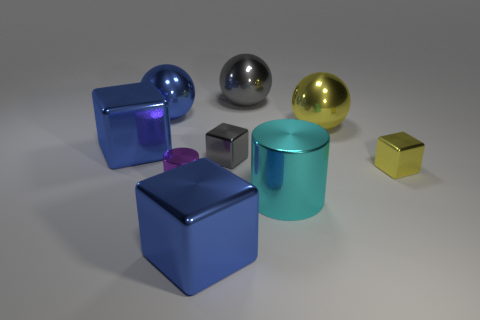How many green objects are large metallic cylinders or large things?
Keep it short and to the point. 0. Are there fewer spheres that are behind the yellow sphere than purple cylinders?
Ensure brevity in your answer.  No. There is a blue shiny cube on the right side of the blue shiny ball; what number of yellow shiny cubes are in front of it?
Ensure brevity in your answer.  0. What number of other objects are there of the same size as the cyan metallic cylinder?
Your answer should be compact. 5. What number of things are large blue cubes or small metallic blocks that are right of the large yellow shiny ball?
Offer a terse response. 3. Are there fewer shiny objects than big green shiny blocks?
Give a very brief answer. No. What is the color of the large cylinder on the right side of the small block left of the yellow metal cube?
Your answer should be compact. Cyan. There is a yellow thing that is the same shape as the big gray metal object; what is it made of?
Provide a succinct answer. Metal. How many rubber objects are cylinders or big blue blocks?
Give a very brief answer. 0. Is the material of the small object to the right of the large cyan metallic cylinder the same as the small block on the left side of the tiny yellow shiny block?
Provide a short and direct response. Yes. 